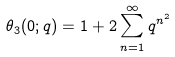Convert formula to latex. <formula><loc_0><loc_0><loc_500><loc_500>\theta _ { 3 } ( 0 ; q ) = 1 + 2 \sum _ { n = 1 } ^ { \infty } q ^ { n ^ { 2 } }</formula> 